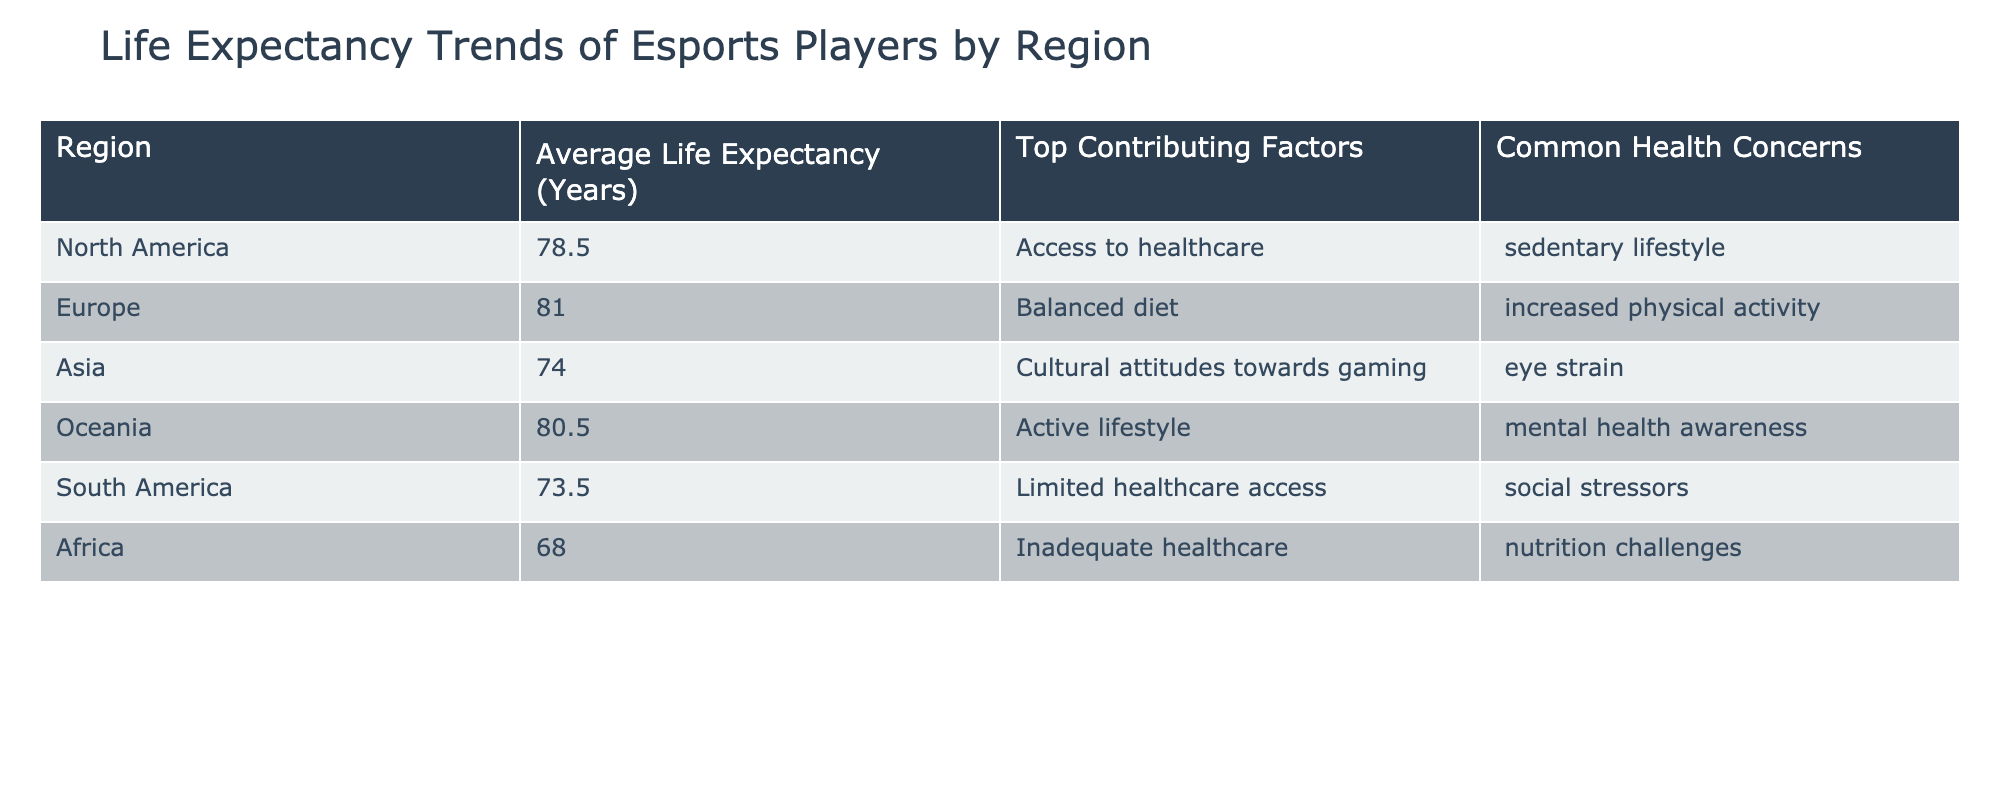What is the average life expectancy of players in North America? The table states that the average life expectancy of players in North America is 78.5 years.
Answer: 78.5 years Which region has the highest average life expectancy? By examining the values in the Average Life Expectancy column, Europe has the highest value at 81.0 years.
Answer: Europe What are the top contributing factors for the life expectancy in Asia? According to the table, the top contributing factors for life expectancy in Asia are cultural attitudes towards gaming and eye strain.
Answer: Cultural attitudes towards gaming, eye strain Is the average life expectancy in South America lower than that in Africa? The average life expectancy in South America is 73.5 years, while in Africa it is 68.0 years. Since 73.5 is greater than 68.0, the statement is false.
Answer: No What is the difference in average life expectancy between Europe and Asia? The average life expectancy in Europe is 81.0 years and in Asia, it is 74.0 years. The difference is 81.0 - 74.0 = 7.0 years.
Answer: 7.0 years What are the common health concerns for players in Oceania? The common health concerns for players in Oceania, as listed in the table, are mental health awareness and active lifestyle.
Answer: Mental health awareness, active lifestyle Does the data suggest that players in Africa have access to better healthcare than those in South America? The table shows that Africa has inadequate healthcare, while South America has limited healthcare access. Thus, the statement suggests that both regions face challenges but does not specifically indicate one has better access than the other. Therefore, it is false.
Answer: No Which region's players are most affected by social stressors? The data indicates that players in South America, who are affected by social stressors, have the lowest average life expectancy at 73.5 years.
Answer: South America If we group the average life expectancy data into two regions, North America and Oceania, what would be their combined average life expectancy? North America has an average of 78.5 years, and Oceania has 80.5 years. The combined average is (78.5 + 80.5) / 2 = 79.5 years.
Answer: 79.5 years 